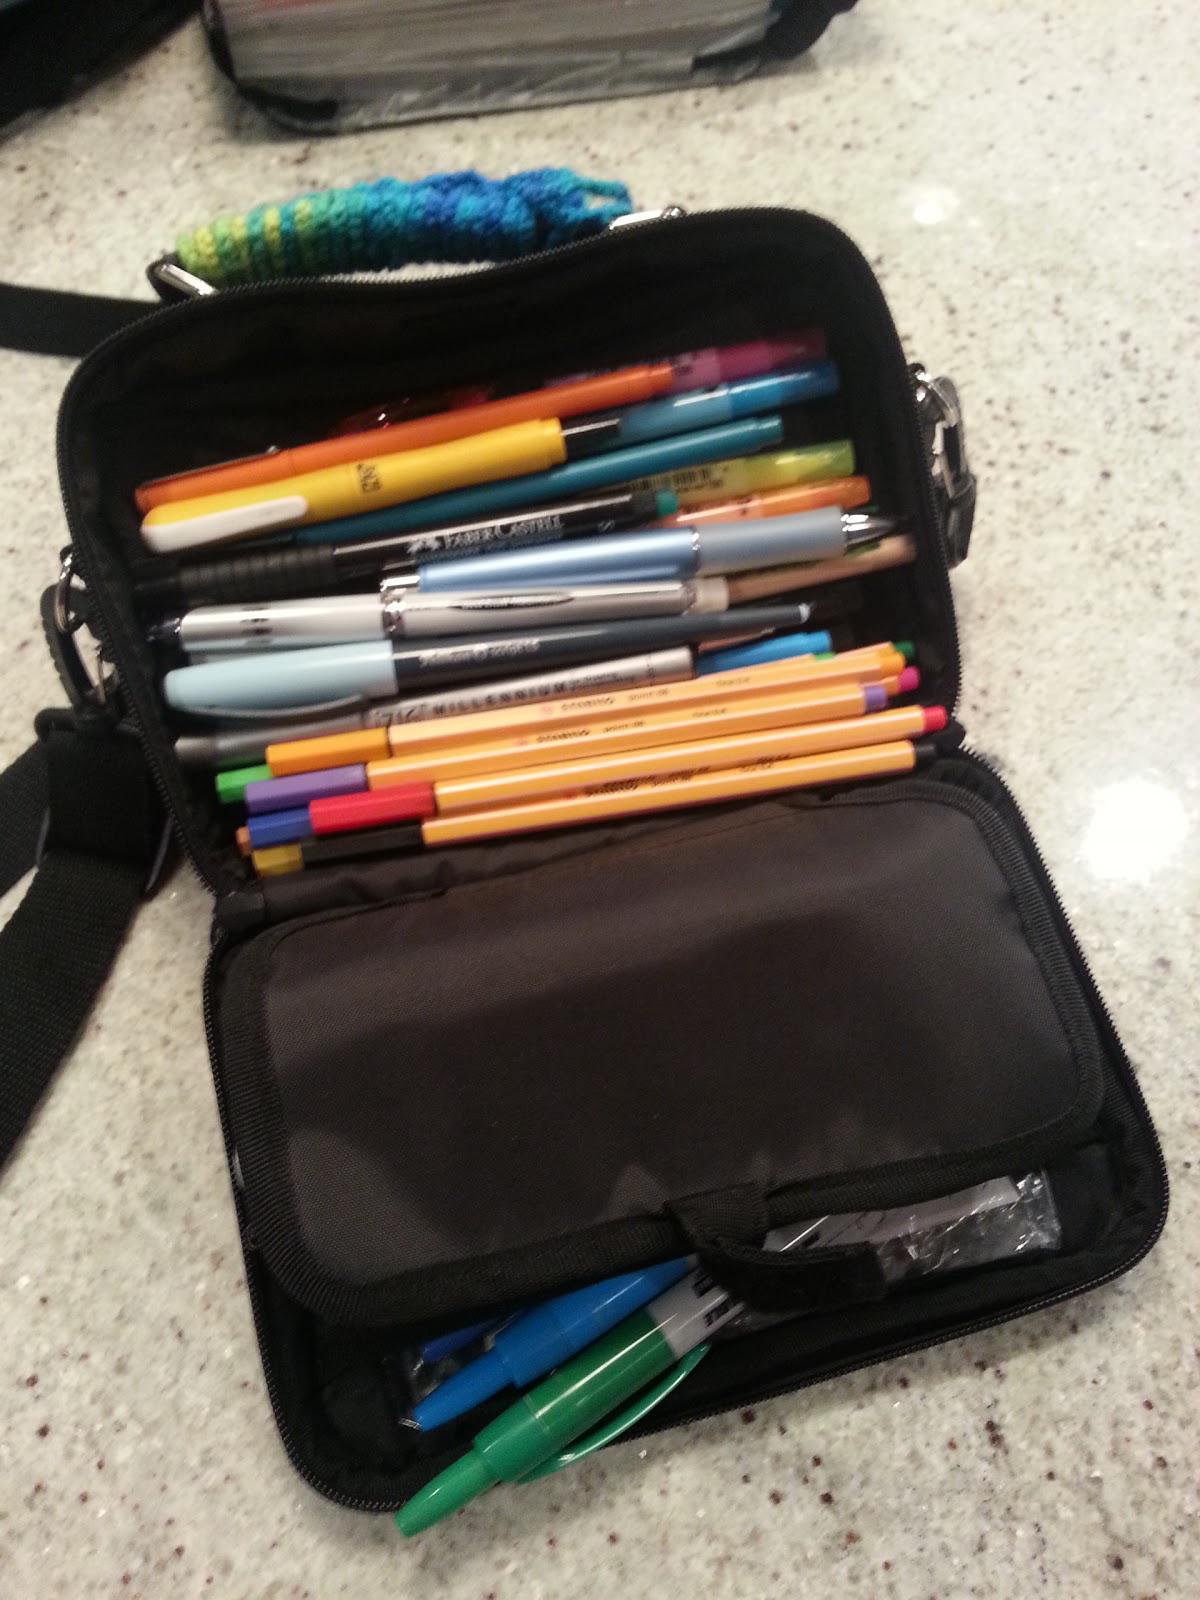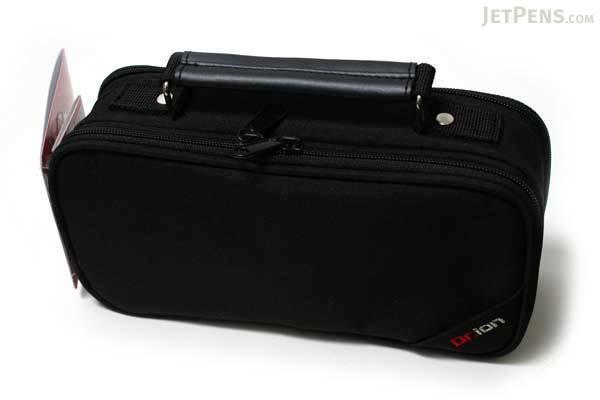The first image is the image on the left, the second image is the image on the right. Assess this claim about the two images: "In one of the images, there is only one black pen holder zipped closed.". Correct or not? Answer yes or no. Yes. The first image is the image on the left, the second image is the image on the right. Analyze the images presented: Is the assertion "At least two of the cases are open." valid? Answer yes or no. No. 